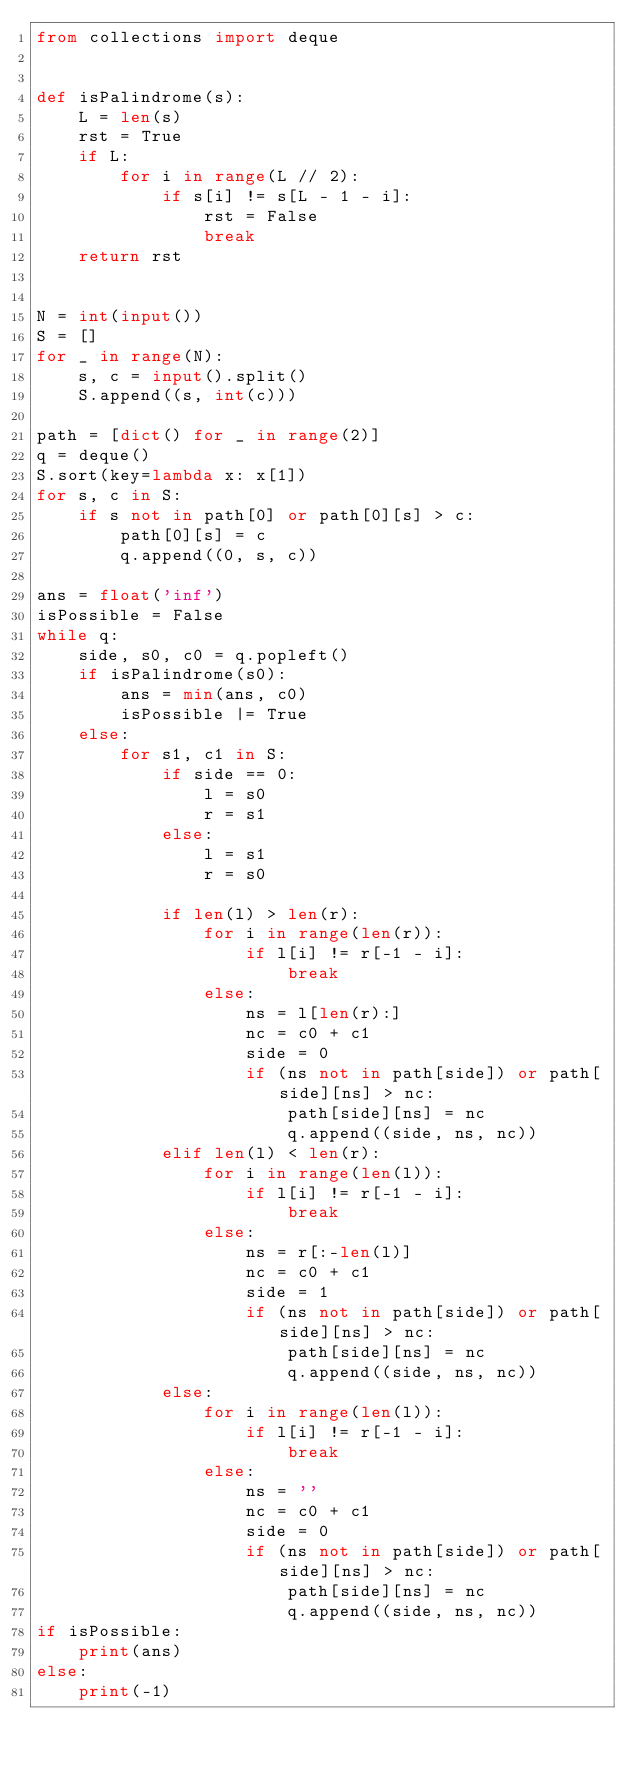<code> <loc_0><loc_0><loc_500><loc_500><_Python_>from collections import deque


def isPalindrome(s):
    L = len(s)
    rst = True
    if L:
        for i in range(L // 2):
            if s[i] != s[L - 1 - i]:
                rst = False
                break
    return rst


N = int(input())
S = []
for _ in range(N):
    s, c = input().split()
    S.append((s, int(c)))

path = [dict() for _ in range(2)]
q = deque()
S.sort(key=lambda x: x[1])
for s, c in S:
    if s not in path[0] or path[0][s] > c:
        path[0][s] = c
        q.append((0, s, c))

ans = float('inf')
isPossible = False
while q:
    side, s0, c0 = q.popleft()
    if isPalindrome(s0):
        ans = min(ans, c0)
        isPossible |= True
    else:
        for s1, c1 in S:
            if side == 0:
                l = s0
                r = s1
            else:
                l = s1
                r = s0

            if len(l) > len(r):
                for i in range(len(r)):
                    if l[i] != r[-1 - i]:
                        break
                else:
                    ns = l[len(r):]
                    nc = c0 + c1
                    side = 0
                    if (ns not in path[side]) or path[side][ns] > nc:
                        path[side][ns] = nc
                        q.append((side, ns, nc))
            elif len(l) < len(r):
                for i in range(len(l)):
                    if l[i] != r[-1 - i]:
                        break
                else:
                    ns = r[:-len(l)]
                    nc = c0 + c1
                    side = 1
                    if (ns not in path[side]) or path[side][ns] > nc:
                        path[side][ns] = nc
                        q.append((side, ns, nc))
            else:
                for i in range(len(l)):
                    if l[i] != r[-1 - i]:
                        break
                else:
                    ns = ''
                    nc = c0 + c1
                    side = 0
                    if (ns not in path[side]) or path[side][ns] > nc:
                        path[side][ns] = nc
                        q.append((side, ns, nc))
if isPossible:
    print(ans)
else:
    print(-1)
</code> 